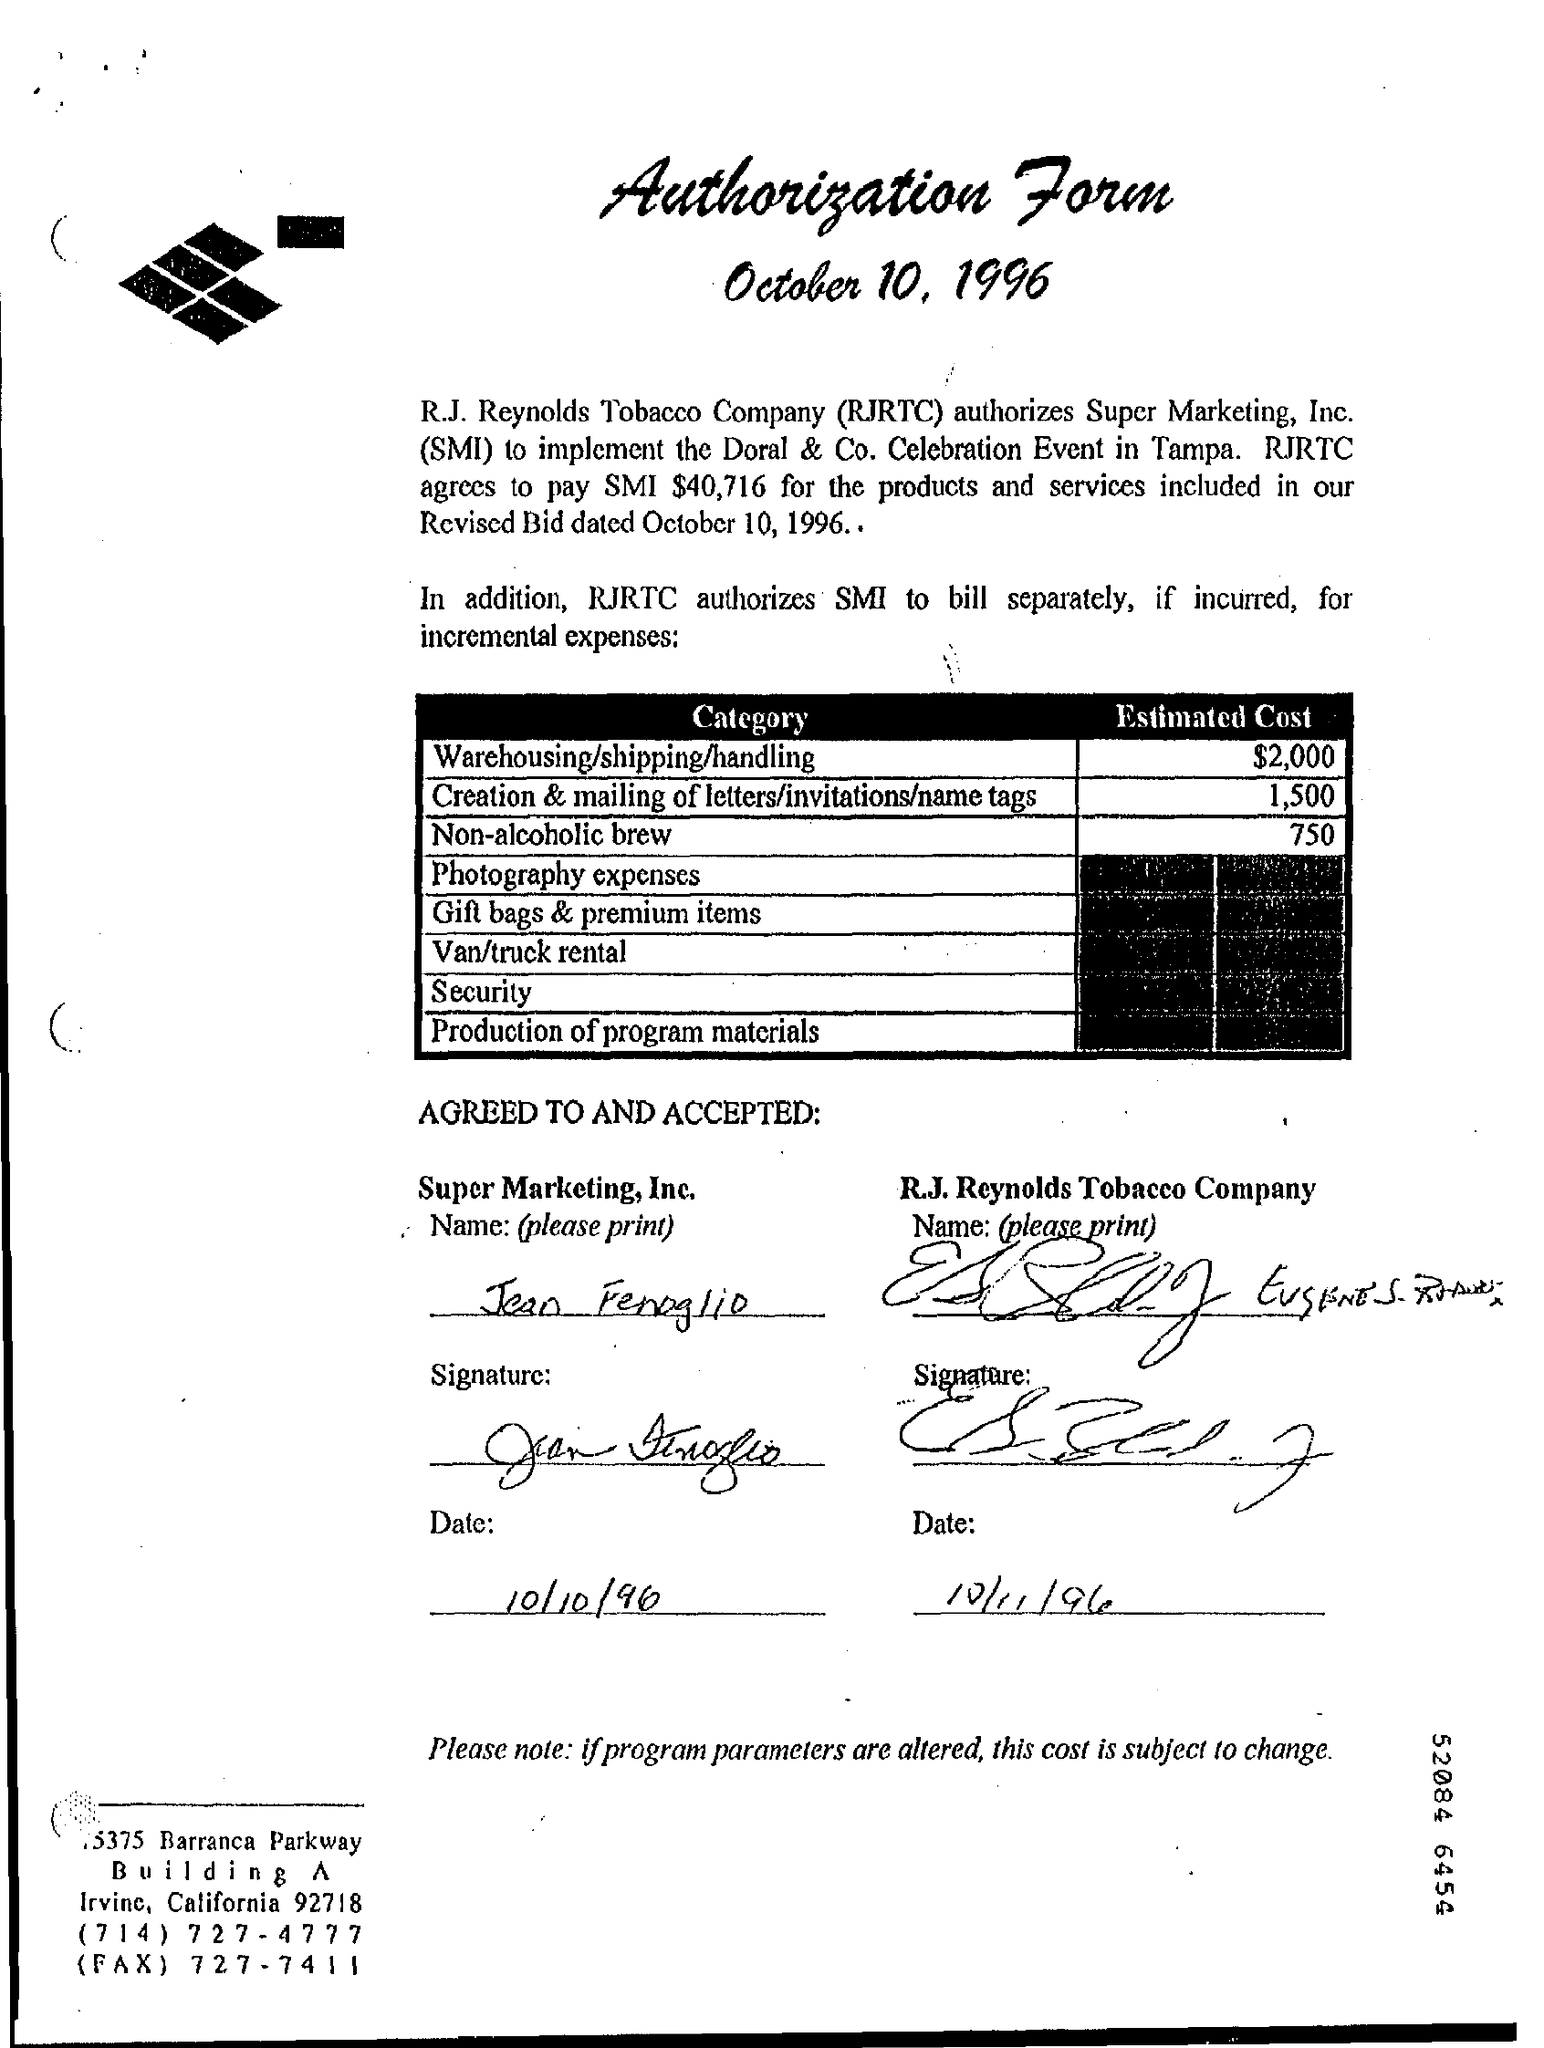What is the Title of the document?
Make the answer very short. Authorization Form. What is the Date?
Provide a short and direct response. October 10, 1996. What is the "Estimated Cost" for "Category" Warehousing/shipping /handling?
Your answer should be very brief. $2,000. What is the "Estimated Cost" for "Category" Creation & mailing of letters/invitations/name tags??
Keep it short and to the point. 1,500. What is the "Estimated Cost" for "Category" Non-alcoholic brew?
Offer a terse response. 750. What amount does RJRTC agree to pay SMI?
Keep it short and to the point. $40,716. 